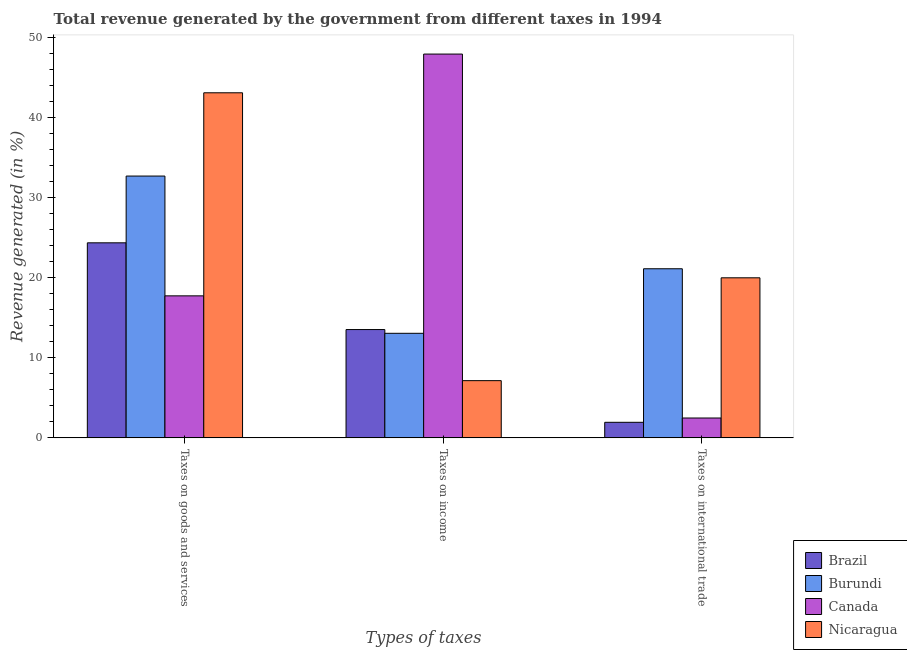How many groups of bars are there?
Make the answer very short. 3. Are the number of bars on each tick of the X-axis equal?
Make the answer very short. Yes. What is the label of the 1st group of bars from the left?
Your answer should be very brief. Taxes on goods and services. What is the percentage of revenue generated by taxes on income in Nicaragua?
Provide a short and direct response. 7.15. Across all countries, what is the maximum percentage of revenue generated by taxes on goods and services?
Keep it short and to the point. 43.1. Across all countries, what is the minimum percentage of revenue generated by tax on international trade?
Your response must be concise. 1.94. In which country was the percentage of revenue generated by taxes on income maximum?
Ensure brevity in your answer.  Canada. In which country was the percentage of revenue generated by taxes on income minimum?
Offer a very short reply. Nicaragua. What is the total percentage of revenue generated by taxes on income in the graph?
Give a very brief answer. 81.66. What is the difference between the percentage of revenue generated by tax on international trade in Nicaragua and that in Brazil?
Make the answer very short. 18.04. What is the difference between the percentage of revenue generated by tax on international trade in Brazil and the percentage of revenue generated by taxes on goods and services in Canada?
Your response must be concise. -15.79. What is the average percentage of revenue generated by tax on international trade per country?
Provide a short and direct response. 11.38. What is the difference between the percentage of revenue generated by taxes on goods and services and percentage of revenue generated by taxes on income in Burundi?
Your answer should be compact. 19.64. What is the ratio of the percentage of revenue generated by tax on international trade in Brazil to that in Burundi?
Give a very brief answer. 0.09. What is the difference between the highest and the second highest percentage of revenue generated by tax on international trade?
Keep it short and to the point. 1.13. What is the difference between the highest and the lowest percentage of revenue generated by taxes on goods and services?
Keep it short and to the point. 25.36. Is the sum of the percentage of revenue generated by taxes on income in Burundi and Brazil greater than the maximum percentage of revenue generated by taxes on goods and services across all countries?
Ensure brevity in your answer.  No. What does the 1st bar from the left in Taxes on international trade represents?
Ensure brevity in your answer.  Brazil. Is it the case that in every country, the sum of the percentage of revenue generated by taxes on goods and services and percentage of revenue generated by taxes on income is greater than the percentage of revenue generated by tax on international trade?
Offer a very short reply. Yes. How many bars are there?
Offer a very short reply. 12. Are all the bars in the graph horizontal?
Your response must be concise. No. What is the difference between two consecutive major ticks on the Y-axis?
Provide a succinct answer. 10. Are the values on the major ticks of Y-axis written in scientific E-notation?
Provide a succinct answer. No. Does the graph contain any zero values?
Ensure brevity in your answer.  No. Does the graph contain grids?
Your response must be concise. No. How many legend labels are there?
Offer a terse response. 4. How are the legend labels stacked?
Make the answer very short. Vertical. What is the title of the graph?
Ensure brevity in your answer.  Total revenue generated by the government from different taxes in 1994. Does "El Salvador" appear as one of the legend labels in the graph?
Ensure brevity in your answer.  No. What is the label or title of the X-axis?
Provide a short and direct response. Types of taxes. What is the label or title of the Y-axis?
Offer a terse response. Revenue generated (in %). What is the Revenue generated (in %) of Brazil in Taxes on goods and services?
Provide a succinct answer. 24.36. What is the Revenue generated (in %) in Burundi in Taxes on goods and services?
Offer a terse response. 32.7. What is the Revenue generated (in %) of Canada in Taxes on goods and services?
Provide a succinct answer. 17.74. What is the Revenue generated (in %) in Nicaragua in Taxes on goods and services?
Your answer should be very brief. 43.1. What is the Revenue generated (in %) of Brazil in Taxes on income?
Keep it short and to the point. 13.53. What is the Revenue generated (in %) of Burundi in Taxes on income?
Offer a very short reply. 13.06. What is the Revenue generated (in %) of Canada in Taxes on income?
Provide a short and direct response. 47.93. What is the Revenue generated (in %) in Nicaragua in Taxes on income?
Your answer should be very brief. 7.15. What is the Revenue generated (in %) in Brazil in Taxes on international trade?
Your response must be concise. 1.94. What is the Revenue generated (in %) in Burundi in Taxes on international trade?
Your response must be concise. 21.12. What is the Revenue generated (in %) in Canada in Taxes on international trade?
Your answer should be very brief. 2.48. What is the Revenue generated (in %) in Nicaragua in Taxes on international trade?
Offer a very short reply. 19.99. Across all Types of taxes, what is the maximum Revenue generated (in %) of Brazil?
Give a very brief answer. 24.36. Across all Types of taxes, what is the maximum Revenue generated (in %) in Burundi?
Provide a short and direct response. 32.7. Across all Types of taxes, what is the maximum Revenue generated (in %) of Canada?
Your answer should be compact. 47.93. Across all Types of taxes, what is the maximum Revenue generated (in %) in Nicaragua?
Provide a succinct answer. 43.1. Across all Types of taxes, what is the minimum Revenue generated (in %) of Brazil?
Make the answer very short. 1.94. Across all Types of taxes, what is the minimum Revenue generated (in %) of Burundi?
Offer a terse response. 13.06. Across all Types of taxes, what is the minimum Revenue generated (in %) of Canada?
Offer a very short reply. 2.48. Across all Types of taxes, what is the minimum Revenue generated (in %) in Nicaragua?
Ensure brevity in your answer.  7.15. What is the total Revenue generated (in %) in Brazil in the graph?
Offer a terse response. 39.83. What is the total Revenue generated (in %) of Burundi in the graph?
Your answer should be compact. 66.87. What is the total Revenue generated (in %) of Canada in the graph?
Your response must be concise. 68.15. What is the total Revenue generated (in %) of Nicaragua in the graph?
Your response must be concise. 70.23. What is the difference between the Revenue generated (in %) in Brazil in Taxes on goods and services and that in Taxes on income?
Provide a succinct answer. 10.83. What is the difference between the Revenue generated (in %) of Burundi in Taxes on goods and services and that in Taxes on income?
Offer a terse response. 19.64. What is the difference between the Revenue generated (in %) of Canada in Taxes on goods and services and that in Taxes on income?
Offer a terse response. -30.19. What is the difference between the Revenue generated (in %) of Nicaragua in Taxes on goods and services and that in Taxes on income?
Offer a terse response. 35.95. What is the difference between the Revenue generated (in %) in Brazil in Taxes on goods and services and that in Taxes on international trade?
Keep it short and to the point. 22.41. What is the difference between the Revenue generated (in %) of Burundi in Taxes on goods and services and that in Taxes on international trade?
Give a very brief answer. 11.58. What is the difference between the Revenue generated (in %) in Canada in Taxes on goods and services and that in Taxes on international trade?
Your answer should be very brief. 15.26. What is the difference between the Revenue generated (in %) in Nicaragua in Taxes on goods and services and that in Taxes on international trade?
Your answer should be very brief. 23.11. What is the difference between the Revenue generated (in %) in Brazil in Taxes on income and that in Taxes on international trade?
Your response must be concise. 11.58. What is the difference between the Revenue generated (in %) of Burundi in Taxes on income and that in Taxes on international trade?
Keep it short and to the point. -8.06. What is the difference between the Revenue generated (in %) of Canada in Taxes on income and that in Taxes on international trade?
Your response must be concise. 45.45. What is the difference between the Revenue generated (in %) in Nicaragua in Taxes on income and that in Taxes on international trade?
Offer a very short reply. -12.84. What is the difference between the Revenue generated (in %) in Brazil in Taxes on goods and services and the Revenue generated (in %) in Burundi in Taxes on income?
Keep it short and to the point. 11.3. What is the difference between the Revenue generated (in %) in Brazil in Taxes on goods and services and the Revenue generated (in %) in Canada in Taxes on income?
Provide a succinct answer. -23.57. What is the difference between the Revenue generated (in %) of Brazil in Taxes on goods and services and the Revenue generated (in %) of Nicaragua in Taxes on income?
Offer a very short reply. 17.21. What is the difference between the Revenue generated (in %) in Burundi in Taxes on goods and services and the Revenue generated (in %) in Canada in Taxes on income?
Your answer should be compact. -15.23. What is the difference between the Revenue generated (in %) in Burundi in Taxes on goods and services and the Revenue generated (in %) in Nicaragua in Taxes on income?
Ensure brevity in your answer.  25.55. What is the difference between the Revenue generated (in %) in Canada in Taxes on goods and services and the Revenue generated (in %) in Nicaragua in Taxes on income?
Your response must be concise. 10.59. What is the difference between the Revenue generated (in %) of Brazil in Taxes on goods and services and the Revenue generated (in %) of Burundi in Taxes on international trade?
Ensure brevity in your answer.  3.24. What is the difference between the Revenue generated (in %) in Brazil in Taxes on goods and services and the Revenue generated (in %) in Canada in Taxes on international trade?
Your answer should be very brief. 21.88. What is the difference between the Revenue generated (in %) in Brazil in Taxes on goods and services and the Revenue generated (in %) in Nicaragua in Taxes on international trade?
Offer a very short reply. 4.37. What is the difference between the Revenue generated (in %) of Burundi in Taxes on goods and services and the Revenue generated (in %) of Canada in Taxes on international trade?
Make the answer very short. 30.22. What is the difference between the Revenue generated (in %) of Burundi in Taxes on goods and services and the Revenue generated (in %) of Nicaragua in Taxes on international trade?
Your response must be concise. 12.71. What is the difference between the Revenue generated (in %) of Canada in Taxes on goods and services and the Revenue generated (in %) of Nicaragua in Taxes on international trade?
Your answer should be very brief. -2.25. What is the difference between the Revenue generated (in %) of Brazil in Taxes on income and the Revenue generated (in %) of Burundi in Taxes on international trade?
Your response must be concise. -7.59. What is the difference between the Revenue generated (in %) in Brazil in Taxes on income and the Revenue generated (in %) in Canada in Taxes on international trade?
Offer a terse response. 11.05. What is the difference between the Revenue generated (in %) in Brazil in Taxes on income and the Revenue generated (in %) in Nicaragua in Taxes on international trade?
Offer a terse response. -6.46. What is the difference between the Revenue generated (in %) of Burundi in Taxes on income and the Revenue generated (in %) of Canada in Taxes on international trade?
Your response must be concise. 10.58. What is the difference between the Revenue generated (in %) in Burundi in Taxes on income and the Revenue generated (in %) in Nicaragua in Taxes on international trade?
Give a very brief answer. -6.93. What is the difference between the Revenue generated (in %) in Canada in Taxes on income and the Revenue generated (in %) in Nicaragua in Taxes on international trade?
Provide a succinct answer. 27.94. What is the average Revenue generated (in %) of Brazil per Types of taxes?
Offer a terse response. 13.28. What is the average Revenue generated (in %) of Burundi per Types of taxes?
Provide a short and direct response. 22.29. What is the average Revenue generated (in %) of Canada per Types of taxes?
Make the answer very short. 22.72. What is the average Revenue generated (in %) in Nicaragua per Types of taxes?
Keep it short and to the point. 23.41. What is the difference between the Revenue generated (in %) in Brazil and Revenue generated (in %) in Burundi in Taxes on goods and services?
Make the answer very short. -8.34. What is the difference between the Revenue generated (in %) in Brazil and Revenue generated (in %) in Canada in Taxes on goods and services?
Give a very brief answer. 6.62. What is the difference between the Revenue generated (in %) of Brazil and Revenue generated (in %) of Nicaragua in Taxes on goods and services?
Your response must be concise. -18.74. What is the difference between the Revenue generated (in %) of Burundi and Revenue generated (in %) of Canada in Taxes on goods and services?
Your response must be concise. 14.96. What is the difference between the Revenue generated (in %) in Burundi and Revenue generated (in %) in Nicaragua in Taxes on goods and services?
Keep it short and to the point. -10.4. What is the difference between the Revenue generated (in %) in Canada and Revenue generated (in %) in Nicaragua in Taxes on goods and services?
Give a very brief answer. -25.36. What is the difference between the Revenue generated (in %) in Brazil and Revenue generated (in %) in Burundi in Taxes on income?
Your answer should be compact. 0.47. What is the difference between the Revenue generated (in %) of Brazil and Revenue generated (in %) of Canada in Taxes on income?
Your response must be concise. -34.4. What is the difference between the Revenue generated (in %) in Brazil and Revenue generated (in %) in Nicaragua in Taxes on income?
Offer a very short reply. 6.38. What is the difference between the Revenue generated (in %) of Burundi and Revenue generated (in %) of Canada in Taxes on income?
Offer a terse response. -34.87. What is the difference between the Revenue generated (in %) of Burundi and Revenue generated (in %) of Nicaragua in Taxes on income?
Ensure brevity in your answer.  5.91. What is the difference between the Revenue generated (in %) of Canada and Revenue generated (in %) of Nicaragua in Taxes on income?
Your answer should be compact. 40.78. What is the difference between the Revenue generated (in %) of Brazil and Revenue generated (in %) of Burundi in Taxes on international trade?
Keep it short and to the point. -19.17. What is the difference between the Revenue generated (in %) in Brazil and Revenue generated (in %) in Canada in Taxes on international trade?
Provide a short and direct response. -0.54. What is the difference between the Revenue generated (in %) in Brazil and Revenue generated (in %) in Nicaragua in Taxes on international trade?
Offer a very short reply. -18.04. What is the difference between the Revenue generated (in %) of Burundi and Revenue generated (in %) of Canada in Taxes on international trade?
Give a very brief answer. 18.64. What is the difference between the Revenue generated (in %) in Burundi and Revenue generated (in %) in Nicaragua in Taxes on international trade?
Give a very brief answer. 1.13. What is the difference between the Revenue generated (in %) of Canada and Revenue generated (in %) of Nicaragua in Taxes on international trade?
Offer a very short reply. -17.51. What is the ratio of the Revenue generated (in %) in Brazil in Taxes on goods and services to that in Taxes on income?
Provide a short and direct response. 1.8. What is the ratio of the Revenue generated (in %) of Burundi in Taxes on goods and services to that in Taxes on income?
Offer a very short reply. 2.5. What is the ratio of the Revenue generated (in %) of Canada in Taxes on goods and services to that in Taxes on income?
Offer a terse response. 0.37. What is the ratio of the Revenue generated (in %) in Nicaragua in Taxes on goods and services to that in Taxes on income?
Ensure brevity in your answer.  6.03. What is the ratio of the Revenue generated (in %) of Brazil in Taxes on goods and services to that in Taxes on international trade?
Ensure brevity in your answer.  12.53. What is the ratio of the Revenue generated (in %) in Burundi in Taxes on goods and services to that in Taxes on international trade?
Make the answer very short. 1.55. What is the ratio of the Revenue generated (in %) in Canada in Taxes on goods and services to that in Taxes on international trade?
Keep it short and to the point. 7.15. What is the ratio of the Revenue generated (in %) in Nicaragua in Taxes on goods and services to that in Taxes on international trade?
Your response must be concise. 2.16. What is the ratio of the Revenue generated (in %) in Brazil in Taxes on income to that in Taxes on international trade?
Provide a short and direct response. 6.96. What is the ratio of the Revenue generated (in %) of Burundi in Taxes on income to that in Taxes on international trade?
Your response must be concise. 0.62. What is the ratio of the Revenue generated (in %) of Canada in Taxes on income to that in Taxes on international trade?
Provide a short and direct response. 19.33. What is the ratio of the Revenue generated (in %) in Nicaragua in Taxes on income to that in Taxes on international trade?
Keep it short and to the point. 0.36. What is the difference between the highest and the second highest Revenue generated (in %) in Brazil?
Make the answer very short. 10.83. What is the difference between the highest and the second highest Revenue generated (in %) of Burundi?
Ensure brevity in your answer.  11.58. What is the difference between the highest and the second highest Revenue generated (in %) of Canada?
Offer a very short reply. 30.19. What is the difference between the highest and the second highest Revenue generated (in %) in Nicaragua?
Provide a succinct answer. 23.11. What is the difference between the highest and the lowest Revenue generated (in %) of Brazil?
Your answer should be very brief. 22.41. What is the difference between the highest and the lowest Revenue generated (in %) in Burundi?
Provide a succinct answer. 19.64. What is the difference between the highest and the lowest Revenue generated (in %) of Canada?
Your answer should be compact. 45.45. What is the difference between the highest and the lowest Revenue generated (in %) of Nicaragua?
Ensure brevity in your answer.  35.95. 